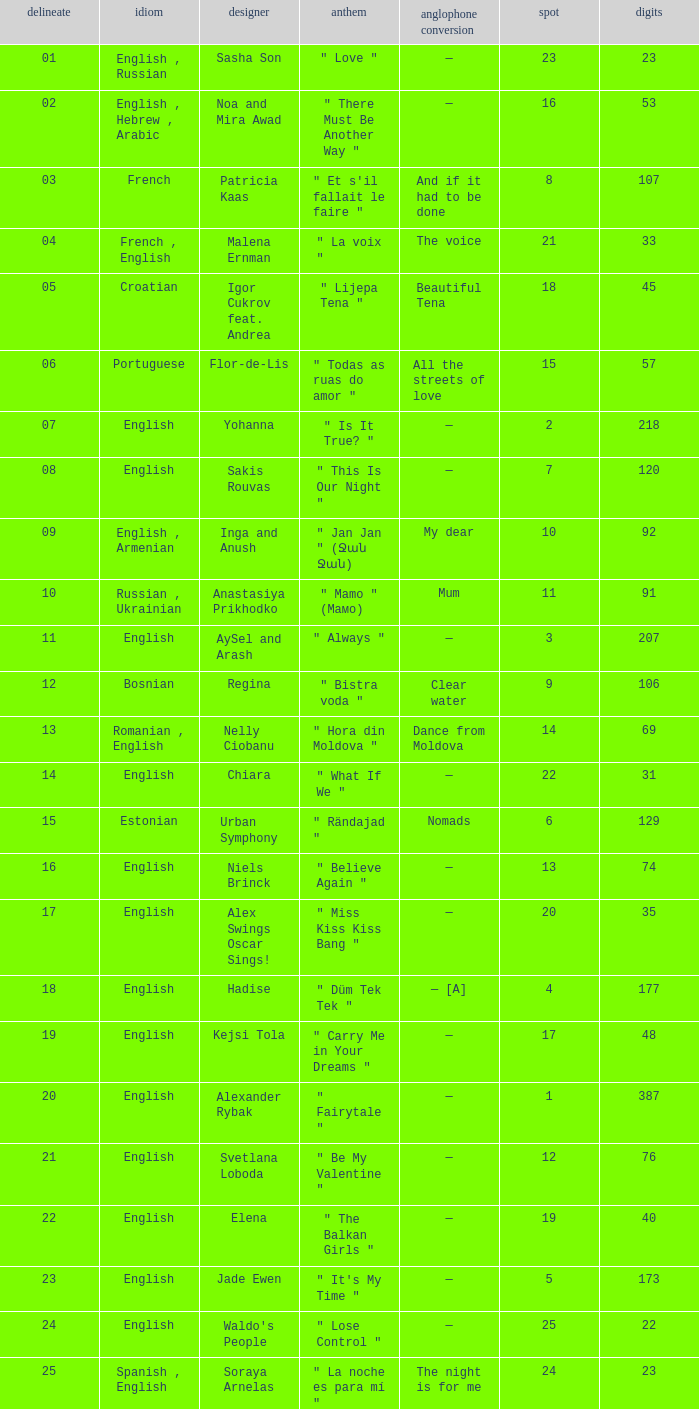What was the average place for the song that had 69 points and a draw smaller than 13? None. 